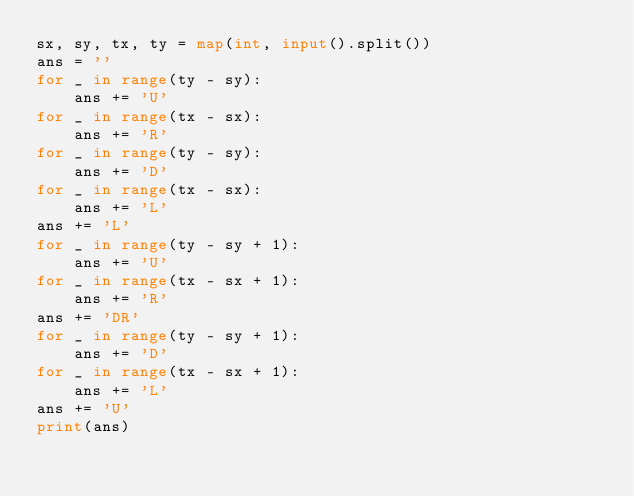Convert code to text. <code><loc_0><loc_0><loc_500><loc_500><_Python_>sx, sy, tx, ty = map(int, input().split())
ans = ''
for _ in range(ty - sy):
    ans += 'U'
for _ in range(tx - sx):
    ans += 'R'
for _ in range(ty - sy):
    ans += 'D'
for _ in range(tx - sx):
    ans += 'L'
ans += 'L'
for _ in range(ty - sy + 1):
    ans += 'U'
for _ in range(tx - sx + 1):
    ans += 'R'
ans += 'DR'
for _ in range(ty - sy + 1):
    ans += 'D'
for _ in range(tx - sx + 1):
    ans += 'L'
ans += 'U'
print(ans)</code> 